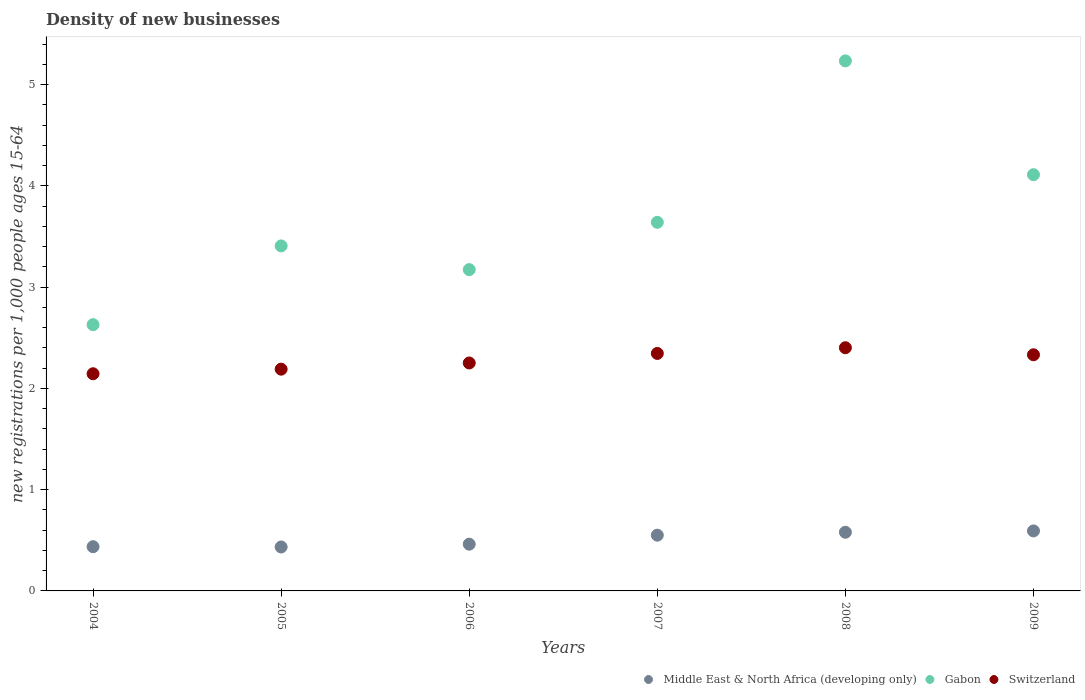How many different coloured dotlines are there?
Provide a succinct answer. 3. Is the number of dotlines equal to the number of legend labels?
Make the answer very short. Yes. What is the number of new registrations in Gabon in 2008?
Your response must be concise. 5.23. Across all years, what is the maximum number of new registrations in Gabon?
Your answer should be very brief. 5.23. Across all years, what is the minimum number of new registrations in Middle East & North Africa (developing only)?
Give a very brief answer. 0.43. In which year was the number of new registrations in Middle East & North Africa (developing only) minimum?
Offer a very short reply. 2005. What is the total number of new registrations in Switzerland in the graph?
Offer a very short reply. 13.66. What is the difference between the number of new registrations in Middle East & North Africa (developing only) in 2005 and that in 2006?
Offer a very short reply. -0.03. What is the difference between the number of new registrations in Switzerland in 2006 and the number of new registrations in Middle East & North Africa (developing only) in 2005?
Provide a short and direct response. 1.82. What is the average number of new registrations in Middle East & North Africa (developing only) per year?
Ensure brevity in your answer.  0.51. In the year 2005, what is the difference between the number of new registrations in Middle East & North Africa (developing only) and number of new registrations in Switzerland?
Provide a short and direct response. -1.76. In how many years, is the number of new registrations in Gabon greater than 2.8?
Give a very brief answer. 5. What is the ratio of the number of new registrations in Middle East & North Africa (developing only) in 2006 to that in 2007?
Your response must be concise. 0.84. Is the difference between the number of new registrations in Middle East & North Africa (developing only) in 2007 and 2009 greater than the difference between the number of new registrations in Switzerland in 2007 and 2009?
Your response must be concise. No. What is the difference between the highest and the second highest number of new registrations in Middle East & North Africa (developing only)?
Offer a terse response. 0.01. What is the difference between the highest and the lowest number of new registrations in Switzerland?
Your answer should be compact. 0.26. Is the sum of the number of new registrations in Gabon in 2005 and 2008 greater than the maximum number of new registrations in Switzerland across all years?
Your answer should be very brief. Yes. Does the number of new registrations in Switzerland monotonically increase over the years?
Provide a short and direct response. No. Is the number of new registrations in Middle East & North Africa (developing only) strictly greater than the number of new registrations in Switzerland over the years?
Offer a very short reply. No. How many dotlines are there?
Keep it short and to the point. 3. How many years are there in the graph?
Provide a short and direct response. 6. What is the difference between two consecutive major ticks on the Y-axis?
Provide a succinct answer. 1. Does the graph contain grids?
Offer a terse response. No. Where does the legend appear in the graph?
Your answer should be compact. Bottom right. How many legend labels are there?
Provide a succinct answer. 3. How are the legend labels stacked?
Provide a succinct answer. Horizontal. What is the title of the graph?
Offer a terse response. Density of new businesses. What is the label or title of the Y-axis?
Ensure brevity in your answer.  New registrations per 1,0 people ages 15-64. What is the new registrations per 1,000 people ages 15-64 in Middle East & North Africa (developing only) in 2004?
Make the answer very short. 0.44. What is the new registrations per 1,000 people ages 15-64 of Gabon in 2004?
Offer a terse response. 2.63. What is the new registrations per 1,000 people ages 15-64 of Switzerland in 2004?
Your answer should be compact. 2.14. What is the new registrations per 1,000 people ages 15-64 of Middle East & North Africa (developing only) in 2005?
Offer a very short reply. 0.43. What is the new registrations per 1,000 people ages 15-64 of Gabon in 2005?
Your answer should be very brief. 3.41. What is the new registrations per 1,000 people ages 15-64 of Switzerland in 2005?
Ensure brevity in your answer.  2.19. What is the new registrations per 1,000 people ages 15-64 in Middle East & North Africa (developing only) in 2006?
Ensure brevity in your answer.  0.46. What is the new registrations per 1,000 people ages 15-64 in Gabon in 2006?
Provide a succinct answer. 3.17. What is the new registrations per 1,000 people ages 15-64 in Switzerland in 2006?
Offer a very short reply. 2.25. What is the new registrations per 1,000 people ages 15-64 in Middle East & North Africa (developing only) in 2007?
Provide a succinct answer. 0.55. What is the new registrations per 1,000 people ages 15-64 of Gabon in 2007?
Offer a very short reply. 3.64. What is the new registrations per 1,000 people ages 15-64 in Switzerland in 2007?
Offer a terse response. 2.35. What is the new registrations per 1,000 people ages 15-64 in Middle East & North Africa (developing only) in 2008?
Your response must be concise. 0.58. What is the new registrations per 1,000 people ages 15-64 in Gabon in 2008?
Offer a terse response. 5.23. What is the new registrations per 1,000 people ages 15-64 of Switzerland in 2008?
Make the answer very short. 2.4. What is the new registrations per 1,000 people ages 15-64 of Middle East & North Africa (developing only) in 2009?
Offer a terse response. 0.59. What is the new registrations per 1,000 people ages 15-64 in Gabon in 2009?
Your answer should be compact. 4.11. What is the new registrations per 1,000 people ages 15-64 of Switzerland in 2009?
Give a very brief answer. 2.33. Across all years, what is the maximum new registrations per 1,000 people ages 15-64 of Middle East & North Africa (developing only)?
Your response must be concise. 0.59. Across all years, what is the maximum new registrations per 1,000 people ages 15-64 of Gabon?
Provide a succinct answer. 5.23. Across all years, what is the maximum new registrations per 1,000 people ages 15-64 in Switzerland?
Make the answer very short. 2.4. Across all years, what is the minimum new registrations per 1,000 people ages 15-64 in Middle East & North Africa (developing only)?
Offer a very short reply. 0.43. Across all years, what is the minimum new registrations per 1,000 people ages 15-64 of Gabon?
Offer a terse response. 2.63. Across all years, what is the minimum new registrations per 1,000 people ages 15-64 in Switzerland?
Offer a very short reply. 2.14. What is the total new registrations per 1,000 people ages 15-64 of Middle East & North Africa (developing only) in the graph?
Your answer should be compact. 3.05. What is the total new registrations per 1,000 people ages 15-64 in Gabon in the graph?
Provide a short and direct response. 22.19. What is the total new registrations per 1,000 people ages 15-64 in Switzerland in the graph?
Your answer should be compact. 13.66. What is the difference between the new registrations per 1,000 people ages 15-64 of Middle East & North Africa (developing only) in 2004 and that in 2005?
Make the answer very short. 0. What is the difference between the new registrations per 1,000 people ages 15-64 in Gabon in 2004 and that in 2005?
Your response must be concise. -0.78. What is the difference between the new registrations per 1,000 people ages 15-64 of Switzerland in 2004 and that in 2005?
Your response must be concise. -0.05. What is the difference between the new registrations per 1,000 people ages 15-64 of Middle East & North Africa (developing only) in 2004 and that in 2006?
Ensure brevity in your answer.  -0.02. What is the difference between the new registrations per 1,000 people ages 15-64 of Gabon in 2004 and that in 2006?
Provide a short and direct response. -0.54. What is the difference between the new registrations per 1,000 people ages 15-64 in Switzerland in 2004 and that in 2006?
Your response must be concise. -0.11. What is the difference between the new registrations per 1,000 people ages 15-64 in Middle East & North Africa (developing only) in 2004 and that in 2007?
Provide a succinct answer. -0.11. What is the difference between the new registrations per 1,000 people ages 15-64 of Gabon in 2004 and that in 2007?
Provide a succinct answer. -1.01. What is the difference between the new registrations per 1,000 people ages 15-64 of Switzerland in 2004 and that in 2007?
Make the answer very short. -0.2. What is the difference between the new registrations per 1,000 people ages 15-64 in Middle East & North Africa (developing only) in 2004 and that in 2008?
Make the answer very short. -0.14. What is the difference between the new registrations per 1,000 people ages 15-64 in Gabon in 2004 and that in 2008?
Provide a short and direct response. -2.6. What is the difference between the new registrations per 1,000 people ages 15-64 in Switzerland in 2004 and that in 2008?
Offer a terse response. -0.26. What is the difference between the new registrations per 1,000 people ages 15-64 of Middle East & North Africa (developing only) in 2004 and that in 2009?
Offer a very short reply. -0.16. What is the difference between the new registrations per 1,000 people ages 15-64 in Gabon in 2004 and that in 2009?
Your response must be concise. -1.48. What is the difference between the new registrations per 1,000 people ages 15-64 of Switzerland in 2004 and that in 2009?
Provide a succinct answer. -0.19. What is the difference between the new registrations per 1,000 people ages 15-64 of Middle East & North Africa (developing only) in 2005 and that in 2006?
Your answer should be compact. -0.03. What is the difference between the new registrations per 1,000 people ages 15-64 of Gabon in 2005 and that in 2006?
Offer a very short reply. 0.23. What is the difference between the new registrations per 1,000 people ages 15-64 of Switzerland in 2005 and that in 2006?
Provide a succinct answer. -0.06. What is the difference between the new registrations per 1,000 people ages 15-64 of Middle East & North Africa (developing only) in 2005 and that in 2007?
Provide a succinct answer. -0.12. What is the difference between the new registrations per 1,000 people ages 15-64 of Gabon in 2005 and that in 2007?
Your response must be concise. -0.23. What is the difference between the new registrations per 1,000 people ages 15-64 in Switzerland in 2005 and that in 2007?
Your answer should be compact. -0.16. What is the difference between the new registrations per 1,000 people ages 15-64 of Middle East & North Africa (developing only) in 2005 and that in 2008?
Keep it short and to the point. -0.15. What is the difference between the new registrations per 1,000 people ages 15-64 in Gabon in 2005 and that in 2008?
Offer a terse response. -1.83. What is the difference between the new registrations per 1,000 people ages 15-64 in Switzerland in 2005 and that in 2008?
Ensure brevity in your answer.  -0.21. What is the difference between the new registrations per 1,000 people ages 15-64 in Middle East & North Africa (developing only) in 2005 and that in 2009?
Provide a succinct answer. -0.16. What is the difference between the new registrations per 1,000 people ages 15-64 of Gabon in 2005 and that in 2009?
Give a very brief answer. -0.7. What is the difference between the new registrations per 1,000 people ages 15-64 of Switzerland in 2005 and that in 2009?
Your response must be concise. -0.14. What is the difference between the new registrations per 1,000 people ages 15-64 in Middle East & North Africa (developing only) in 2006 and that in 2007?
Your answer should be very brief. -0.09. What is the difference between the new registrations per 1,000 people ages 15-64 of Gabon in 2006 and that in 2007?
Make the answer very short. -0.47. What is the difference between the new registrations per 1,000 people ages 15-64 in Switzerland in 2006 and that in 2007?
Keep it short and to the point. -0.09. What is the difference between the new registrations per 1,000 people ages 15-64 of Middle East & North Africa (developing only) in 2006 and that in 2008?
Offer a very short reply. -0.12. What is the difference between the new registrations per 1,000 people ages 15-64 of Gabon in 2006 and that in 2008?
Offer a terse response. -2.06. What is the difference between the new registrations per 1,000 people ages 15-64 of Switzerland in 2006 and that in 2008?
Keep it short and to the point. -0.15. What is the difference between the new registrations per 1,000 people ages 15-64 of Middle East & North Africa (developing only) in 2006 and that in 2009?
Give a very brief answer. -0.13. What is the difference between the new registrations per 1,000 people ages 15-64 of Gabon in 2006 and that in 2009?
Provide a short and direct response. -0.94. What is the difference between the new registrations per 1,000 people ages 15-64 in Switzerland in 2006 and that in 2009?
Make the answer very short. -0.08. What is the difference between the new registrations per 1,000 people ages 15-64 in Middle East & North Africa (developing only) in 2007 and that in 2008?
Ensure brevity in your answer.  -0.03. What is the difference between the new registrations per 1,000 people ages 15-64 in Gabon in 2007 and that in 2008?
Offer a terse response. -1.59. What is the difference between the new registrations per 1,000 people ages 15-64 in Switzerland in 2007 and that in 2008?
Your answer should be compact. -0.06. What is the difference between the new registrations per 1,000 people ages 15-64 in Middle East & North Africa (developing only) in 2007 and that in 2009?
Offer a very short reply. -0.04. What is the difference between the new registrations per 1,000 people ages 15-64 of Gabon in 2007 and that in 2009?
Your response must be concise. -0.47. What is the difference between the new registrations per 1,000 people ages 15-64 of Switzerland in 2007 and that in 2009?
Give a very brief answer. 0.01. What is the difference between the new registrations per 1,000 people ages 15-64 of Middle East & North Africa (developing only) in 2008 and that in 2009?
Provide a succinct answer. -0.01. What is the difference between the new registrations per 1,000 people ages 15-64 in Gabon in 2008 and that in 2009?
Your response must be concise. 1.12. What is the difference between the new registrations per 1,000 people ages 15-64 of Switzerland in 2008 and that in 2009?
Make the answer very short. 0.07. What is the difference between the new registrations per 1,000 people ages 15-64 of Middle East & North Africa (developing only) in 2004 and the new registrations per 1,000 people ages 15-64 of Gabon in 2005?
Keep it short and to the point. -2.97. What is the difference between the new registrations per 1,000 people ages 15-64 in Middle East & North Africa (developing only) in 2004 and the new registrations per 1,000 people ages 15-64 in Switzerland in 2005?
Offer a very short reply. -1.75. What is the difference between the new registrations per 1,000 people ages 15-64 of Gabon in 2004 and the new registrations per 1,000 people ages 15-64 of Switzerland in 2005?
Keep it short and to the point. 0.44. What is the difference between the new registrations per 1,000 people ages 15-64 of Middle East & North Africa (developing only) in 2004 and the new registrations per 1,000 people ages 15-64 of Gabon in 2006?
Keep it short and to the point. -2.74. What is the difference between the new registrations per 1,000 people ages 15-64 in Middle East & North Africa (developing only) in 2004 and the new registrations per 1,000 people ages 15-64 in Switzerland in 2006?
Ensure brevity in your answer.  -1.81. What is the difference between the new registrations per 1,000 people ages 15-64 in Gabon in 2004 and the new registrations per 1,000 people ages 15-64 in Switzerland in 2006?
Your answer should be compact. 0.38. What is the difference between the new registrations per 1,000 people ages 15-64 in Middle East & North Africa (developing only) in 2004 and the new registrations per 1,000 people ages 15-64 in Gabon in 2007?
Make the answer very short. -3.2. What is the difference between the new registrations per 1,000 people ages 15-64 in Middle East & North Africa (developing only) in 2004 and the new registrations per 1,000 people ages 15-64 in Switzerland in 2007?
Provide a short and direct response. -1.91. What is the difference between the new registrations per 1,000 people ages 15-64 of Gabon in 2004 and the new registrations per 1,000 people ages 15-64 of Switzerland in 2007?
Your answer should be very brief. 0.28. What is the difference between the new registrations per 1,000 people ages 15-64 of Middle East & North Africa (developing only) in 2004 and the new registrations per 1,000 people ages 15-64 of Gabon in 2008?
Your answer should be compact. -4.8. What is the difference between the new registrations per 1,000 people ages 15-64 of Middle East & North Africa (developing only) in 2004 and the new registrations per 1,000 people ages 15-64 of Switzerland in 2008?
Offer a terse response. -1.96. What is the difference between the new registrations per 1,000 people ages 15-64 in Gabon in 2004 and the new registrations per 1,000 people ages 15-64 in Switzerland in 2008?
Give a very brief answer. 0.23. What is the difference between the new registrations per 1,000 people ages 15-64 of Middle East & North Africa (developing only) in 2004 and the new registrations per 1,000 people ages 15-64 of Gabon in 2009?
Your answer should be compact. -3.67. What is the difference between the new registrations per 1,000 people ages 15-64 of Middle East & North Africa (developing only) in 2004 and the new registrations per 1,000 people ages 15-64 of Switzerland in 2009?
Ensure brevity in your answer.  -1.9. What is the difference between the new registrations per 1,000 people ages 15-64 in Gabon in 2004 and the new registrations per 1,000 people ages 15-64 in Switzerland in 2009?
Your answer should be very brief. 0.3. What is the difference between the new registrations per 1,000 people ages 15-64 of Middle East & North Africa (developing only) in 2005 and the new registrations per 1,000 people ages 15-64 of Gabon in 2006?
Ensure brevity in your answer.  -2.74. What is the difference between the new registrations per 1,000 people ages 15-64 in Middle East & North Africa (developing only) in 2005 and the new registrations per 1,000 people ages 15-64 in Switzerland in 2006?
Keep it short and to the point. -1.82. What is the difference between the new registrations per 1,000 people ages 15-64 of Gabon in 2005 and the new registrations per 1,000 people ages 15-64 of Switzerland in 2006?
Your answer should be very brief. 1.16. What is the difference between the new registrations per 1,000 people ages 15-64 of Middle East & North Africa (developing only) in 2005 and the new registrations per 1,000 people ages 15-64 of Gabon in 2007?
Your response must be concise. -3.21. What is the difference between the new registrations per 1,000 people ages 15-64 in Middle East & North Africa (developing only) in 2005 and the new registrations per 1,000 people ages 15-64 in Switzerland in 2007?
Your answer should be compact. -1.91. What is the difference between the new registrations per 1,000 people ages 15-64 of Gabon in 2005 and the new registrations per 1,000 people ages 15-64 of Switzerland in 2007?
Offer a very short reply. 1.06. What is the difference between the new registrations per 1,000 people ages 15-64 in Middle East & North Africa (developing only) in 2005 and the new registrations per 1,000 people ages 15-64 in Gabon in 2008?
Ensure brevity in your answer.  -4.8. What is the difference between the new registrations per 1,000 people ages 15-64 in Middle East & North Africa (developing only) in 2005 and the new registrations per 1,000 people ages 15-64 in Switzerland in 2008?
Offer a very short reply. -1.97. What is the difference between the new registrations per 1,000 people ages 15-64 of Gabon in 2005 and the new registrations per 1,000 people ages 15-64 of Switzerland in 2008?
Keep it short and to the point. 1.01. What is the difference between the new registrations per 1,000 people ages 15-64 in Middle East & North Africa (developing only) in 2005 and the new registrations per 1,000 people ages 15-64 in Gabon in 2009?
Provide a short and direct response. -3.68. What is the difference between the new registrations per 1,000 people ages 15-64 in Middle East & North Africa (developing only) in 2005 and the new registrations per 1,000 people ages 15-64 in Switzerland in 2009?
Provide a succinct answer. -1.9. What is the difference between the new registrations per 1,000 people ages 15-64 of Gabon in 2005 and the new registrations per 1,000 people ages 15-64 of Switzerland in 2009?
Ensure brevity in your answer.  1.08. What is the difference between the new registrations per 1,000 people ages 15-64 of Middle East & North Africa (developing only) in 2006 and the new registrations per 1,000 people ages 15-64 of Gabon in 2007?
Offer a very short reply. -3.18. What is the difference between the new registrations per 1,000 people ages 15-64 of Middle East & North Africa (developing only) in 2006 and the new registrations per 1,000 people ages 15-64 of Switzerland in 2007?
Your response must be concise. -1.88. What is the difference between the new registrations per 1,000 people ages 15-64 of Gabon in 2006 and the new registrations per 1,000 people ages 15-64 of Switzerland in 2007?
Keep it short and to the point. 0.83. What is the difference between the new registrations per 1,000 people ages 15-64 of Middle East & North Africa (developing only) in 2006 and the new registrations per 1,000 people ages 15-64 of Gabon in 2008?
Provide a succinct answer. -4.77. What is the difference between the new registrations per 1,000 people ages 15-64 in Middle East & North Africa (developing only) in 2006 and the new registrations per 1,000 people ages 15-64 in Switzerland in 2008?
Offer a terse response. -1.94. What is the difference between the new registrations per 1,000 people ages 15-64 of Gabon in 2006 and the new registrations per 1,000 people ages 15-64 of Switzerland in 2008?
Ensure brevity in your answer.  0.77. What is the difference between the new registrations per 1,000 people ages 15-64 in Middle East & North Africa (developing only) in 2006 and the new registrations per 1,000 people ages 15-64 in Gabon in 2009?
Your answer should be compact. -3.65. What is the difference between the new registrations per 1,000 people ages 15-64 of Middle East & North Africa (developing only) in 2006 and the new registrations per 1,000 people ages 15-64 of Switzerland in 2009?
Your answer should be compact. -1.87. What is the difference between the new registrations per 1,000 people ages 15-64 in Gabon in 2006 and the new registrations per 1,000 people ages 15-64 in Switzerland in 2009?
Provide a short and direct response. 0.84. What is the difference between the new registrations per 1,000 people ages 15-64 of Middle East & North Africa (developing only) in 2007 and the new registrations per 1,000 people ages 15-64 of Gabon in 2008?
Your answer should be compact. -4.68. What is the difference between the new registrations per 1,000 people ages 15-64 of Middle East & North Africa (developing only) in 2007 and the new registrations per 1,000 people ages 15-64 of Switzerland in 2008?
Ensure brevity in your answer.  -1.85. What is the difference between the new registrations per 1,000 people ages 15-64 in Gabon in 2007 and the new registrations per 1,000 people ages 15-64 in Switzerland in 2008?
Offer a very short reply. 1.24. What is the difference between the new registrations per 1,000 people ages 15-64 in Middle East & North Africa (developing only) in 2007 and the new registrations per 1,000 people ages 15-64 in Gabon in 2009?
Provide a short and direct response. -3.56. What is the difference between the new registrations per 1,000 people ages 15-64 in Middle East & North Africa (developing only) in 2007 and the new registrations per 1,000 people ages 15-64 in Switzerland in 2009?
Give a very brief answer. -1.78. What is the difference between the new registrations per 1,000 people ages 15-64 in Gabon in 2007 and the new registrations per 1,000 people ages 15-64 in Switzerland in 2009?
Keep it short and to the point. 1.31. What is the difference between the new registrations per 1,000 people ages 15-64 in Middle East & North Africa (developing only) in 2008 and the new registrations per 1,000 people ages 15-64 in Gabon in 2009?
Keep it short and to the point. -3.53. What is the difference between the new registrations per 1,000 people ages 15-64 in Middle East & North Africa (developing only) in 2008 and the new registrations per 1,000 people ages 15-64 in Switzerland in 2009?
Keep it short and to the point. -1.75. What is the difference between the new registrations per 1,000 people ages 15-64 in Gabon in 2008 and the new registrations per 1,000 people ages 15-64 in Switzerland in 2009?
Provide a succinct answer. 2.9. What is the average new registrations per 1,000 people ages 15-64 in Middle East & North Africa (developing only) per year?
Ensure brevity in your answer.  0.51. What is the average new registrations per 1,000 people ages 15-64 of Gabon per year?
Provide a succinct answer. 3.7. What is the average new registrations per 1,000 people ages 15-64 of Switzerland per year?
Make the answer very short. 2.28. In the year 2004, what is the difference between the new registrations per 1,000 people ages 15-64 in Middle East & North Africa (developing only) and new registrations per 1,000 people ages 15-64 in Gabon?
Provide a succinct answer. -2.19. In the year 2004, what is the difference between the new registrations per 1,000 people ages 15-64 in Middle East & North Africa (developing only) and new registrations per 1,000 people ages 15-64 in Switzerland?
Give a very brief answer. -1.71. In the year 2004, what is the difference between the new registrations per 1,000 people ages 15-64 of Gabon and new registrations per 1,000 people ages 15-64 of Switzerland?
Provide a succinct answer. 0.48. In the year 2005, what is the difference between the new registrations per 1,000 people ages 15-64 in Middle East & North Africa (developing only) and new registrations per 1,000 people ages 15-64 in Gabon?
Your response must be concise. -2.97. In the year 2005, what is the difference between the new registrations per 1,000 people ages 15-64 in Middle East & North Africa (developing only) and new registrations per 1,000 people ages 15-64 in Switzerland?
Offer a terse response. -1.76. In the year 2005, what is the difference between the new registrations per 1,000 people ages 15-64 in Gabon and new registrations per 1,000 people ages 15-64 in Switzerland?
Give a very brief answer. 1.22. In the year 2006, what is the difference between the new registrations per 1,000 people ages 15-64 of Middle East & North Africa (developing only) and new registrations per 1,000 people ages 15-64 of Gabon?
Ensure brevity in your answer.  -2.71. In the year 2006, what is the difference between the new registrations per 1,000 people ages 15-64 in Middle East & North Africa (developing only) and new registrations per 1,000 people ages 15-64 in Switzerland?
Ensure brevity in your answer.  -1.79. In the year 2006, what is the difference between the new registrations per 1,000 people ages 15-64 of Gabon and new registrations per 1,000 people ages 15-64 of Switzerland?
Your answer should be compact. 0.92. In the year 2007, what is the difference between the new registrations per 1,000 people ages 15-64 in Middle East & North Africa (developing only) and new registrations per 1,000 people ages 15-64 in Gabon?
Give a very brief answer. -3.09. In the year 2007, what is the difference between the new registrations per 1,000 people ages 15-64 of Middle East & North Africa (developing only) and new registrations per 1,000 people ages 15-64 of Switzerland?
Keep it short and to the point. -1.79. In the year 2007, what is the difference between the new registrations per 1,000 people ages 15-64 in Gabon and new registrations per 1,000 people ages 15-64 in Switzerland?
Provide a succinct answer. 1.29. In the year 2008, what is the difference between the new registrations per 1,000 people ages 15-64 in Middle East & North Africa (developing only) and new registrations per 1,000 people ages 15-64 in Gabon?
Provide a short and direct response. -4.65. In the year 2008, what is the difference between the new registrations per 1,000 people ages 15-64 of Middle East & North Africa (developing only) and new registrations per 1,000 people ages 15-64 of Switzerland?
Offer a very short reply. -1.82. In the year 2008, what is the difference between the new registrations per 1,000 people ages 15-64 in Gabon and new registrations per 1,000 people ages 15-64 in Switzerland?
Ensure brevity in your answer.  2.83. In the year 2009, what is the difference between the new registrations per 1,000 people ages 15-64 of Middle East & North Africa (developing only) and new registrations per 1,000 people ages 15-64 of Gabon?
Your response must be concise. -3.52. In the year 2009, what is the difference between the new registrations per 1,000 people ages 15-64 in Middle East & North Africa (developing only) and new registrations per 1,000 people ages 15-64 in Switzerland?
Provide a succinct answer. -1.74. In the year 2009, what is the difference between the new registrations per 1,000 people ages 15-64 of Gabon and new registrations per 1,000 people ages 15-64 of Switzerland?
Your answer should be very brief. 1.78. What is the ratio of the new registrations per 1,000 people ages 15-64 in Middle East & North Africa (developing only) in 2004 to that in 2005?
Your answer should be very brief. 1.01. What is the ratio of the new registrations per 1,000 people ages 15-64 in Gabon in 2004 to that in 2005?
Give a very brief answer. 0.77. What is the ratio of the new registrations per 1,000 people ages 15-64 in Switzerland in 2004 to that in 2005?
Your response must be concise. 0.98. What is the ratio of the new registrations per 1,000 people ages 15-64 of Middle East & North Africa (developing only) in 2004 to that in 2006?
Offer a terse response. 0.95. What is the ratio of the new registrations per 1,000 people ages 15-64 in Gabon in 2004 to that in 2006?
Your answer should be compact. 0.83. What is the ratio of the new registrations per 1,000 people ages 15-64 in Switzerland in 2004 to that in 2006?
Provide a short and direct response. 0.95. What is the ratio of the new registrations per 1,000 people ages 15-64 of Middle East & North Africa (developing only) in 2004 to that in 2007?
Give a very brief answer. 0.79. What is the ratio of the new registrations per 1,000 people ages 15-64 in Gabon in 2004 to that in 2007?
Keep it short and to the point. 0.72. What is the ratio of the new registrations per 1,000 people ages 15-64 in Switzerland in 2004 to that in 2007?
Provide a short and direct response. 0.91. What is the ratio of the new registrations per 1,000 people ages 15-64 in Middle East & North Africa (developing only) in 2004 to that in 2008?
Give a very brief answer. 0.75. What is the ratio of the new registrations per 1,000 people ages 15-64 in Gabon in 2004 to that in 2008?
Offer a very short reply. 0.5. What is the ratio of the new registrations per 1,000 people ages 15-64 in Switzerland in 2004 to that in 2008?
Your response must be concise. 0.89. What is the ratio of the new registrations per 1,000 people ages 15-64 in Middle East & North Africa (developing only) in 2004 to that in 2009?
Offer a terse response. 0.74. What is the ratio of the new registrations per 1,000 people ages 15-64 in Gabon in 2004 to that in 2009?
Provide a succinct answer. 0.64. What is the ratio of the new registrations per 1,000 people ages 15-64 of Switzerland in 2004 to that in 2009?
Your answer should be very brief. 0.92. What is the ratio of the new registrations per 1,000 people ages 15-64 of Middle East & North Africa (developing only) in 2005 to that in 2006?
Your answer should be very brief. 0.94. What is the ratio of the new registrations per 1,000 people ages 15-64 of Gabon in 2005 to that in 2006?
Ensure brevity in your answer.  1.07. What is the ratio of the new registrations per 1,000 people ages 15-64 in Switzerland in 2005 to that in 2006?
Provide a short and direct response. 0.97. What is the ratio of the new registrations per 1,000 people ages 15-64 in Middle East & North Africa (developing only) in 2005 to that in 2007?
Your answer should be compact. 0.79. What is the ratio of the new registrations per 1,000 people ages 15-64 in Gabon in 2005 to that in 2007?
Your answer should be very brief. 0.94. What is the ratio of the new registrations per 1,000 people ages 15-64 in Switzerland in 2005 to that in 2007?
Keep it short and to the point. 0.93. What is the ratio of the new registrations per 1,000 people ages 15-64 of Middle East & North Africa (developing only) in 2005 to that in 2008?
Offer a very short reply. 0.75. What is the ratio of the new registrations per 1,000 people ages 15-64 of Gabon in 2005 to that in 2008?
Your answer should be compact. 0.65. What is the ratio of the new registrations per 1,000 people ages 15-64 in Switzerland in 2005 to that in 2008?
Provide a short and direct response. 0.91. What is the ratio of the new registrations per 1,000 people ages 15-64 in Middle East & North Africa (developing only) in 2005 to that in 2009?
Offer a terse response. 0.73. What is the ratio of the new registrations per 1,000 people ages 15-64 of Gabon in 2005 to that in 2009?
Give a very brief answer. 0.83. What is the ratio of the new registrations per 1,000 people ages 15-64 in Switzerland in 2005 to that in 2009?
Provide a short and direct response. 0.94. What is the ratio of the new registrations per 1,000 people ages 15-64 in Middle East & North Africa (developing only) in 2006 to that in 2007?
Provide a succinct answer. 0.84. What is the ratio of the new registrations per 1,000 people ages 15-64 of Gabon in 2006 to that in 2007?
Ensure brevity in your answer.  0.87. What is the ratio of the new registrations per 1,000 people ages 15-64 of Switzerland in 2006 to that in 2007?
Provide a succinct answer. 0.96. What is the ratio of the new registrations per 1,000 people ages 15-64 of Middle East & North Africa (developing only) in 2006 to that in 2008?
Provide a succinct answer. 0.8. What is the ratio of the new registrations per 1,000 people ages 15-64 in Gabon in 2006 to that in 2008?
Your answer should be very brief. 0.61. What is the ratio of the new registrations per 1,000 people ages 15-64 of Switzerland in 2006 to that in 2008?
Provide a short and direct response. 0.94. What is the ratio of the new registrations per 1,000 people ages 15-64 in Middle East & North Africa (developing only) in 2006 to that in 2009?
Your response must be concise. 0.78. What is the ratio of the new registrations per 1,000 people ages 15-64 in Gabon in 2006 to that in 2009?
Ensure brevity in your answer.  0.77. What is the ratio of the new registrations per 1,000 people ages 15-64 of Switzerland in 2006 to that in 2009?
Give a very brief answer. 0.97. What is the ratio of the new registrations per 1,000 people ages 15-64 of Middle East & North Africa (developing only) in 2007 to that in 2008?
Your answer should be very brief. 0.95. What is the ratio of the new registrations per 1,000 people ages 15-64 in Gabon in 2007 to that in 2008?
Keep it short and to the point. 0.7. What is the ratio of the new registrations per 1,000 people ages 15-64 of Switzerland in 2007 to that in 2008?
Provide a short and direct response. 0.98. What is the ratio of the new registrations per 1,000 people ages 15-64 in Middle East & North Africa (developing only) in 2007 to that in 2009?
Keep it short and to the point. 0.93. What is the ratio of the new registrations per 1,000 people ages 15-64 in Gabon in 2007 to that in 2009?
Offer a very short reply. 0.89. What is the ratio of the new registrations per 1,000 people ages 15-64 in Middle East & North Africa (developing only) in 2008 to that in 2009?
Ensure brevity in your answer.  0.98. What is the ratio of the new registrations per 1,000 people ages 15-64 in Gabon in 2008 to that in 2009?
Your answer should be very brief. 1.27. What is the ratio of the new registrations per 1,000 people ages 15-64 in Switzerland in 2008 to that in 2009?
Make the answer very short. 1.03. What is the difference between the highest and the second highest new registrations per 1,000 people ages 15-64 of Middle East & North Africa (developing only)?
Your answer should be compact. 0.01. What is the difference between the highest and the second highest new registrations per 1,000 people ages 15-64 of Gabon?
Offer a terse response. 1.12. What is the difference between the highest and the second highest new registrations per 1,000 people ages 15-64 of Switzerland?
Provide a succinct answer. 0.06. What is the difference between the highest and the lowest new registrations per 1,000 people ages 15-64 of Middle East & North Africa (developing only)?
Make the answer very short. 0.16. What is the difference between the highest and the lowest new registrations per 1,000 people ages 15-64 of Gabon?
Provide a short and direct response. 2.6. What is the difference between the highest and the lowest new registrations per 1,000 people ages 15-64 in Switzerland?
Give a very brief answer. 0.26. 